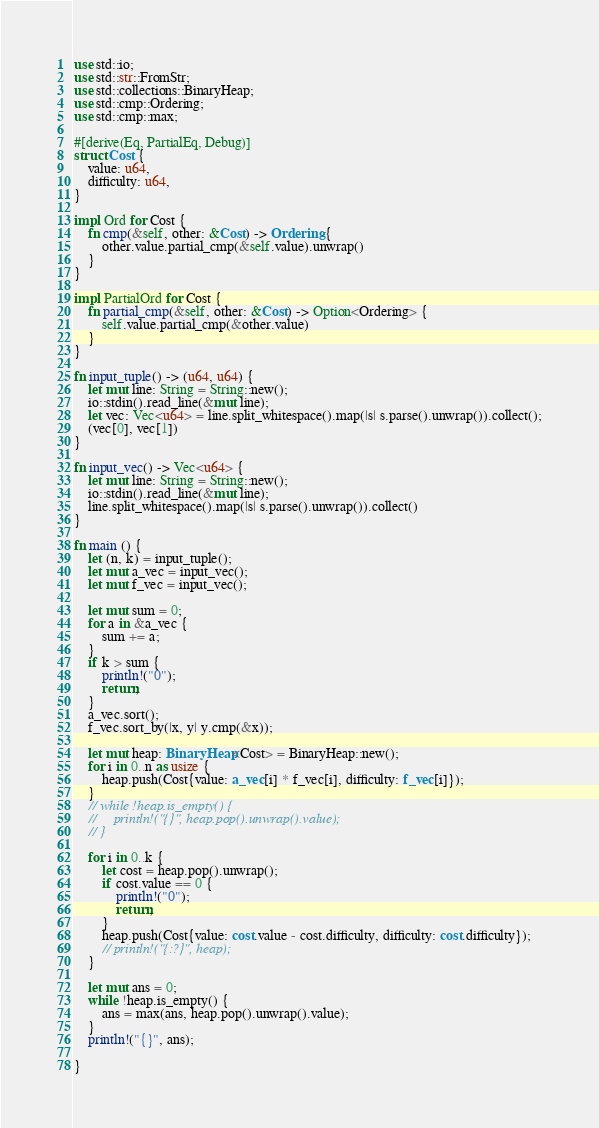<code> <loc_0><loc_0><loc_500><loc_500><_Rust_>use std::io;
use std::str::FromStr;
use std::collections::BinaryHeap;
use std::cmp::Ordering;
use std::cmp::max;

#[derive(Eq, PartialEq, Debug)]
struct Cost {
    value: u64,
    difficulty: u64,
}

impl Ord for Cost {
    fn cmp(&self, other: &Cost) -> Ordering {
        other.value.partial_cmp(&self.value).unwrap()
    }
}

impl PartialOrd for Cost {
    fn partial_cmp(&self, other: &Cost) -> Option<Ordering> {
        self.value.partial_cmp(&other.value)
    }
}

fn input_tuple() -> (u64, u64) {
    let mut line: String = String::new();
    io::stdin().read_line(&mut line);
    let vec: Vec<u64> = line.split_whitespace().map(|s| s.parse().unwrap()).collect();
    (vec[0], vec[1])
}

fn input_vec() -> Vec<u64> {
    let mut line: String = String::new();
    io::stdin().read_line(&mut line);
    line.split_whitespace().map(|s| s.parse().unwrap()).collect()
}

fn main () {
    let (n, k) = input_tuple();
    let mut a_vec = input_vec();
    let mut f_vec = input_vec();

    let mut sum = 0;
    for a in &a_vec {
        sum += a;
    }
    if k > sum {
        println!("0");
        return;
    }
    a_vec.sort();
    f_vec.sort_by(|x, y| y.cmp(&x));

    let mut heap: BinaryHeap<Cost> = BinaryHeap::new();
    for i in 0..n as usize {
        heap.push(Cost{value: a_vec[i] * f_vec[i], difficulty: f_vec[i]});
    }
    // while !heap.is_empty() {
    //     println!("{}", heap.pop().unwrap().value);
    // }

    for i in 0..k {
        let cost = heap.pop().unwrap();
        if cost.value == 0 {
            println!("0");
            return;
        }
        heap.push(Cost{value: cost.value - cost.difficulty, difficulty: cost.difficulty});
        // println!("{:?}", heap);
    }

    let mut ans = 0;
    while !heap.is_empty() {
        ans = max(ans, heap.pop().unwrap().value);
    }
    println!("{}", ans);
    
}</code> 